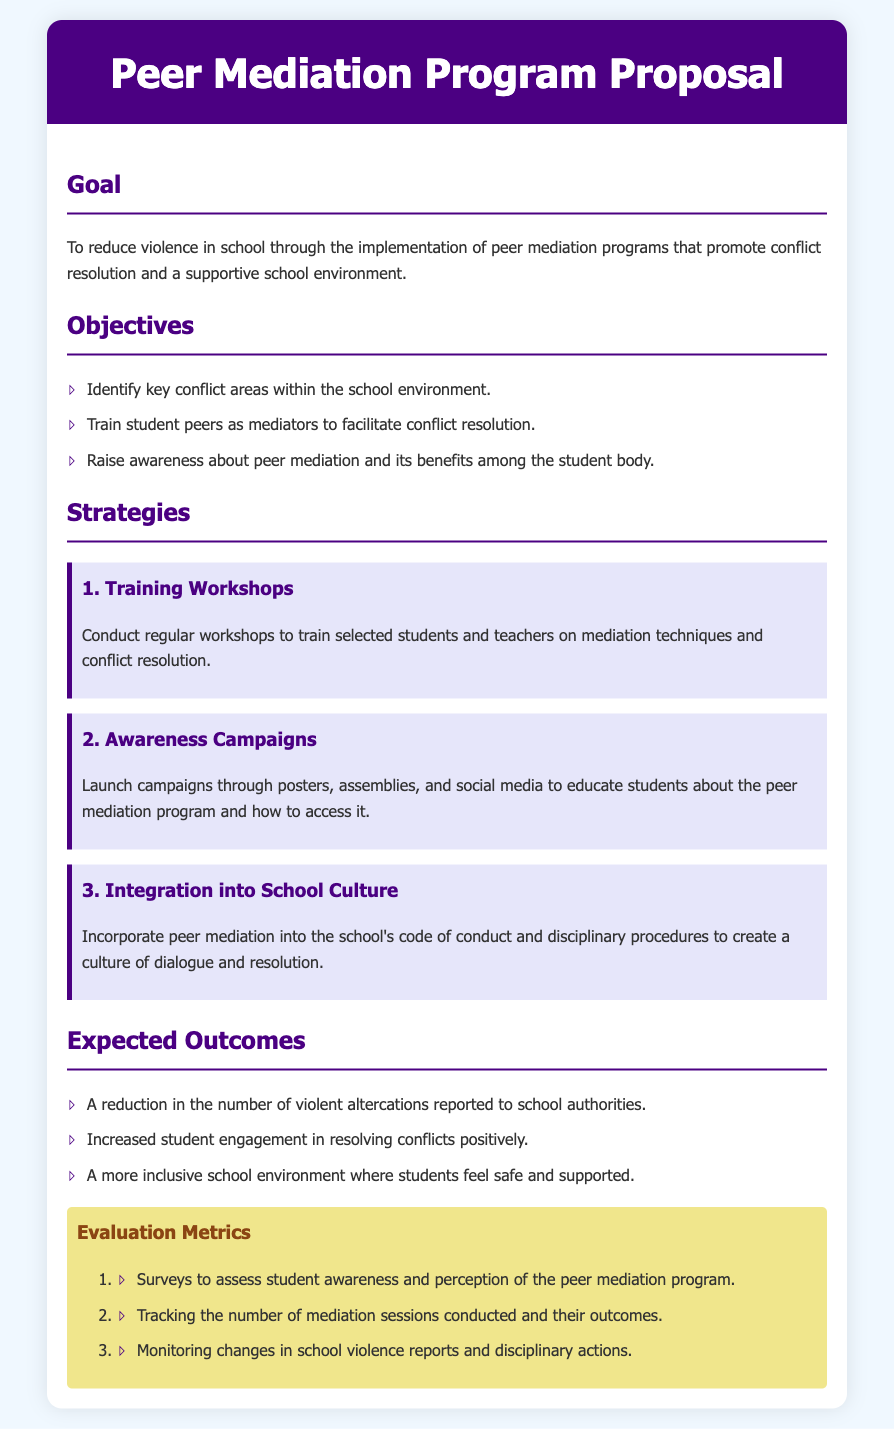What is the main goal of the Peer Mediation Program? The main goal is to reduce violence in school through the implementation of peer mediation programs that promote conflict resolution and a supportive school environment.
Answer: Reduce violence in school What is one key objective of the program? One key objective is to train student peers as mediators to facilitate conflict resolution.
Answer: Train student peers as mediators How many strategies are outlined in the document? The document outlines three strategies for the program.
Answer: Three What is the first strategy mentioned? The first strategy mentioned is conducting regular workshops to train selected students and teachers on mediation techniques and conflict resolution.
Answer: Training Workshops What type of campaigns will be launched according to the proposal? Awareness campaigns will be launched through posters, assemblies, and social media to educate students about the peer mediation program.
Answer: Awareness campaigns What is one expected outcome of the program? One expected outcome is a reduction in the number of violent altercations reported to school authorities.
Answer: Reduction in violent altercations What assessment method will be used to evaluate student awareness of the program? Surveys will be conducted to assess student awareness and perception of the peer mediation program.
Answer: Surveys How will the program be integrated into school culture? The program will be incorporated into the school's code of conduct and disciplinary procedures to create a culture of dialogue and resolution.
Answer: School's code of conduct What color is the header background in the document? The header background color in the document is purple.
Answer: Purple 